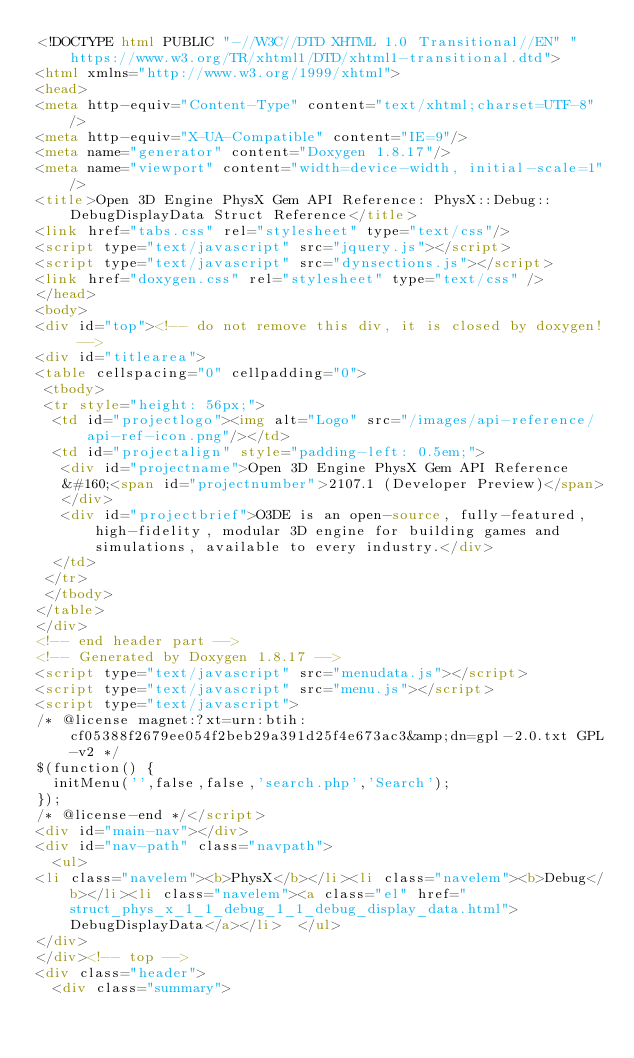<code> <loc_0><loc_0><loc_500><loc_500><_HTML_><!DOCTYPE html PUBLIC "-//W3C//DTD XHTML 1.0 Transitional//EN" "https://www.w3.org/TR/xhtml1/DTD/xhtml1-transitional.dtd">
<html xmlns="http://www.w3.org/1999/xhtml">
<head>
<meta http-equiv="Content-Type" content="text/xhtml;charset=UTF-8"/>
<meta http-equiv="X-UA-Compatible" content="IE=9"/>
<meta name="generator" content="Doxygen 1.8.17"/>
<meta name="viewport" content="width=device-width, initial-scale=1"/>
<title>Open 3D Engine PhysX Gem API Reference: PhysX::Debug::DebugDisplayData Struct Reference</title>
<link href="tabs.css" rel="stylesheet" type="text/css"/>
<script type="text/javascript" src="jquery.js"></script>
<script type="text/javascript" src="dynsections.js"></script>
<link href="doxygen.css" rel="stylesheet" type="text/css" />
</head>
<body>
<div id="top"><!-- do not remove this div, it is closed by doxygen! -->
<div id="titlearea">
<table cellspacing="0" cellpadding="0">
 <tbody>
 <tr style="height: 56px;">
  <td id="projectlogo"><img alt="Logo" src="/images/api-reference/api-ref-icon.png"/></td>
  <td id="projectalign" style="padding-left: 0.5em;">
   <div id="projectname">Open 3D Engine PhysX Gem API Reference
   &#160;<span id="projectnumber">2107.1 (Developer Preview)</span>
   </div>
   <div id="projectbrief">O3DE is an open-source, fully-featured, high-fidelity, modular 3D engine for building games and simulations, available to every industry.</div>
  </td>
 </tr>
 </tbody>
</table>
</div>
<!-- end header part -->
<!-- Generated by Doxygen 1.8.17 -->
<script type="text/javascript" src="menudata.js"></script>
<script type="text/javascript" src="menu.js"></script>
<script type="text/javascript">
/* @license magnet:?xt=urn:btih:cf05388f2679ee054f2beb29a391d25f4e673ac3&amp;dn=gpl-2.0.txt GPL-v2 */
$(function() {
  initMenu('',false,false,'search.php','Search');
});
/* @license-end */</script>
<div id="main-nav"></div>
<div id="nav-path" class="navpath">
  <ul>
<li class="navelem"><b>PhysX</b></li><li class="navelem"><b>Debug</b></li><li class="navelem"><a class="el" href="struct_phys_x_1_1_debug_1_1_debug_display_data.html">DebugDisplayData</a></li>  </ul>
</div>
</div><!-- top -->
<div class="header">
  <div class="summary"></code> 